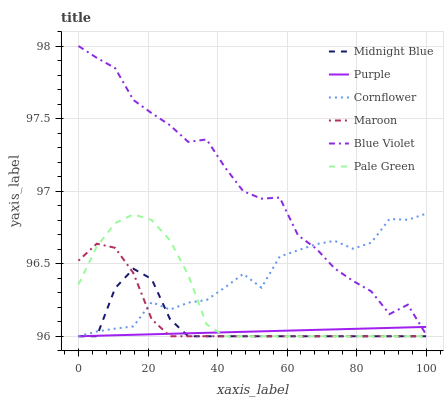Does Purple have the minimum area under the curve?
Answer yes or no. Yes. Does Blue Violet have the maximum area under the curve?
Answer yes or no. Yes. Does Midnight Blue have the minimum area under the curve?
Answer yes or no. No. Does Midnight Blue have the maximum area under the curve?
Answer yes or no. No. Is Purple the smoothest?
Answer yes or no. Yes. Is Blue Violet the roughest?
Answer yes or no. Yes. Is Midnight Blue the smoothest?
Answer yes or no. No. Is Midnight Blue the roughest?
Answer yes or no. No. Does Midnight Blue have the lowest value?
Answer yes or no. Yes. Does Blue Violet have the lowest value?
Answer yes or no. No. Does Blue Violet have the highest value?
Answer yes or no. Yes. Does Midnight Blue have the highest value?
Answer yes or no. No. Is Purple less than Cornflower?
Answer yes or no. Yes. Is Blue Violet greater than Pale Green?
Answer yes or no. Yes. Does Purple intersect Blue Violet?
Answer yes or no. Yes. Is Purple less than Blue Violet?
Answer yes or no. No. Is Purple greater than Blue Violet?
Answer yes or no. No. Does Purple intersect Cornflower?
Answer yes or no. No. 